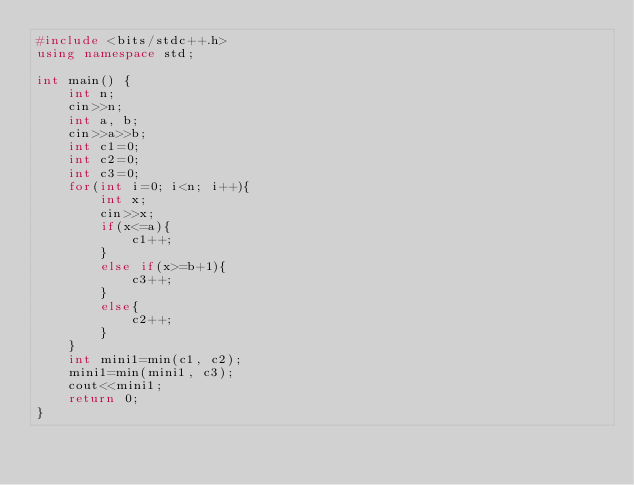Convert code to text. <code><loc_0><loc_0><loc_500><loc_500><_C++_>#include <bits/stdc++.h>
using namespace std;

int main() {
	int n;
	cin>>n;
	int a, b;
	cin>>a>>b;
	int c1=0;
	int c2=0;
	int c3=0;
	for(int i=0; i<n; i++){
		int x;
		cin>>x;
		if(x<=a){
			c1++;
		}
		else if(x>=b+1){
			c3++;
		}
		else{
			c2++;
		}
	}
	int mini1=min(c1, c2);
	mini1=min(mini1, c3);
	cout<<mini1;
	return 0;
}</code> 